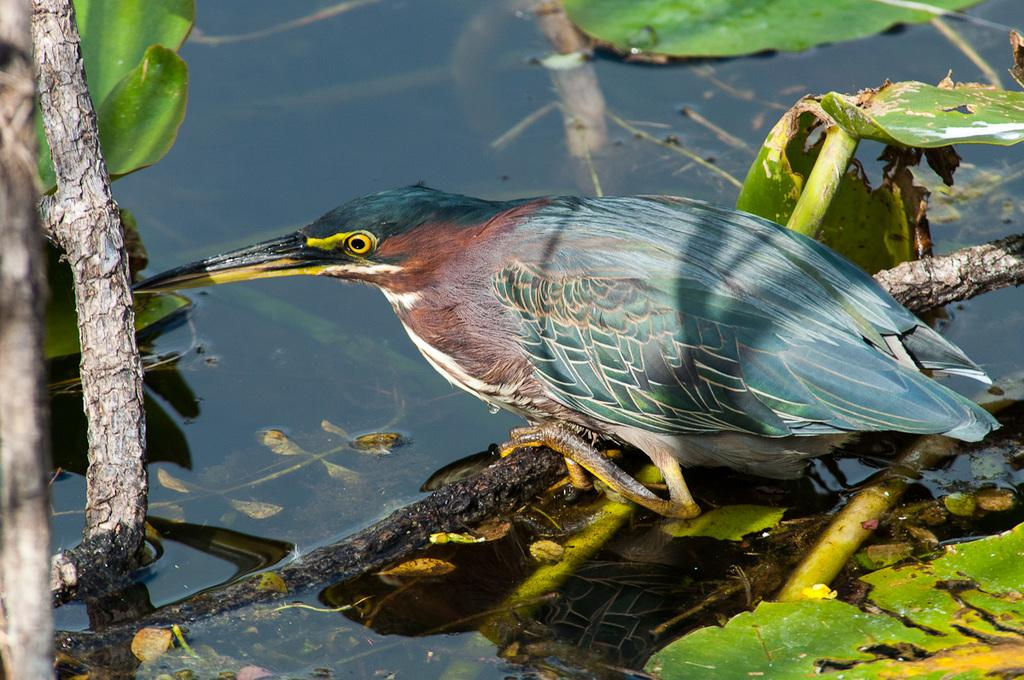What type of animal can be seen in the image? There is a bird in the image. Where is the bird located? The bird is sitting on a stem of a tree. What can be seen in the background of the image? There is water visible in the image. What is present in the water? There are twigs and leaves in the water. What type of wool can be seen in the image? There is no wool present in the image. How many cubs are visible in the image? There are no cubs present in the image. 